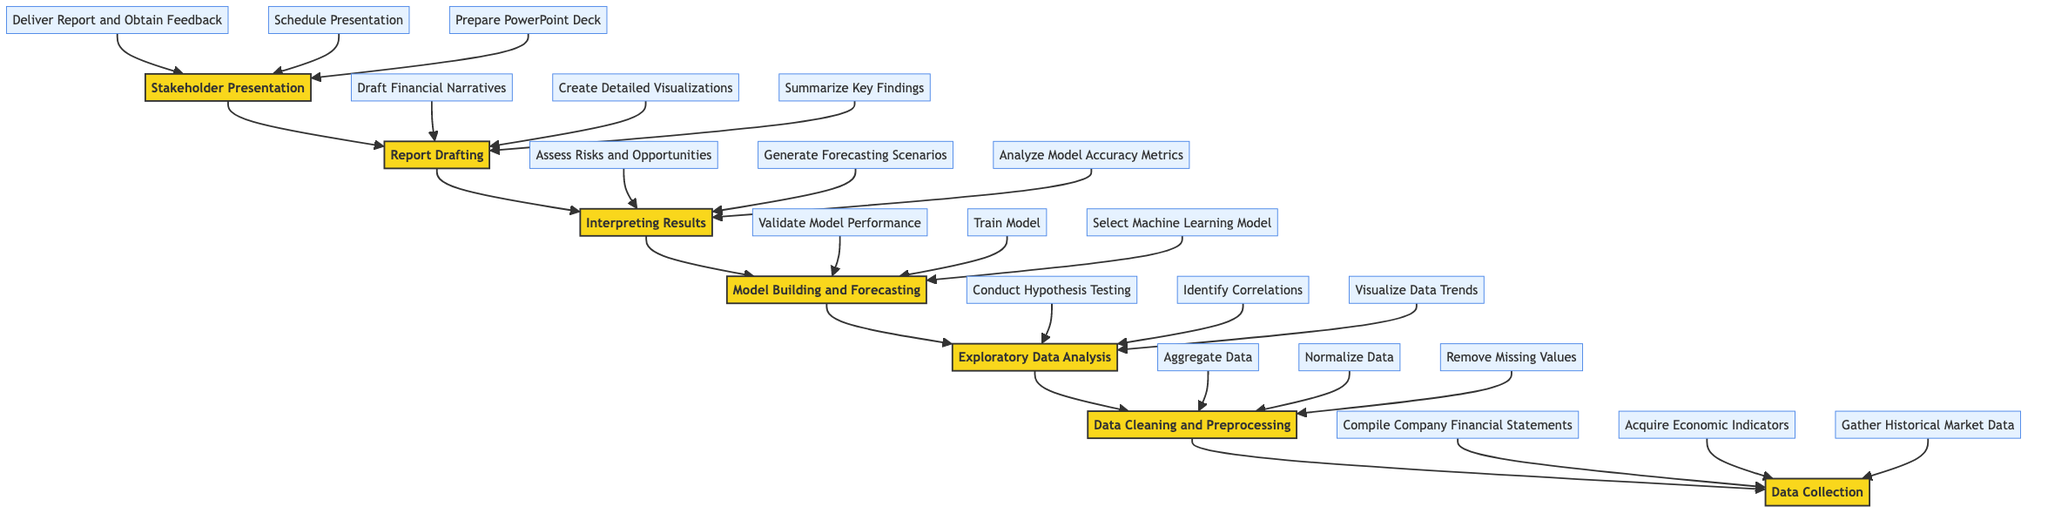What is the first phase in the flow chart? The flow chart starts with the phase labeled "Data Collection," which is located at the bottom of the diagram, indicating that it is the first step in the overall process.
Answer: Data Collection How many elements are in the "Report Drafting" phase? The "Report Drafting" phase consists of three elements: "Summarize Key Findings in an Executive Summary," "Create Detailed Visualizations using Tableau," and "Draft Financial Narratives Supported by Data Insights."
Answer: 3 Which phase comes immediately before the "Stakeholder Presentation"? The phase directly before "Stakeholder Presentation" is "Report Drafting," which indicates the report must be drafted prior to presenting it to stakeholders.
Answer: Report Drafting What is the last step to be completed before the "Interpreting Results" phase? The last step before "Interpreting Results" is "Model Building and Forecasting." The diagram indicates a sequential process flowing upward, so model building is completed before interpreting results.
Answer: Model Building and Forecasting How many phases are there in total in the flow chart? The flow chart illustrates seven distinct phases: "Data Collection," "Data Cleaning and Preprocessing," "Exploratory Data Analysis," "Model Building and Forecasting," "Interpreting Results," "Report Drafting," and "Stakeholder Presentation." Counting these reveals a total of seven phases.
Answer: 7 Which element in the "Model Building and Forecasting" phase is focused on optimizing model performance? The element that deals with optimizing model performance is "Validate Model Performance with Cross-Validation." This element ensures that the model performs well before it is used for forecasting.
Answer: Validate Model Performance What connects the "Data Collection" phase to the "Data Cleaning and Preprocessing" phase? The arrow connects the "Data Collection" phase to the "Data Cleaning and Preprocessing," indicating a flow that shows data must be collected before it can be cleaned and preprocessed.
Answer: Arrow In which phase is hypothesis testing conducted? Hypothesis testing is conducted in the "Exploratory Data Analysis" phase. This phase allows for examining relationships and trends in data, which includes testing hypotheses.
Answer: Exploratory Data Analysis What element summarizes key findings in the report? The element that summarizes key findings is "Summarize Key Findings in an Executive Summary." It is an essential part of the report drafting process, providing concise insights.
Answer: Summarize Key Findings 